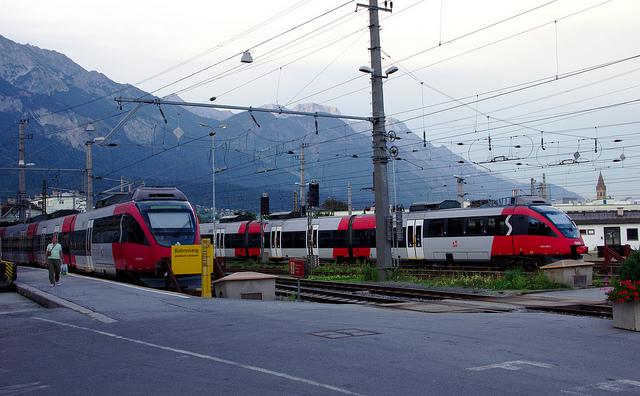What letter is painted on the ground?
Concise answer only. F. How many people are walking in the photo?
Keep it brief. 1. How many different trains are there?
Write a very short answer. 2. 